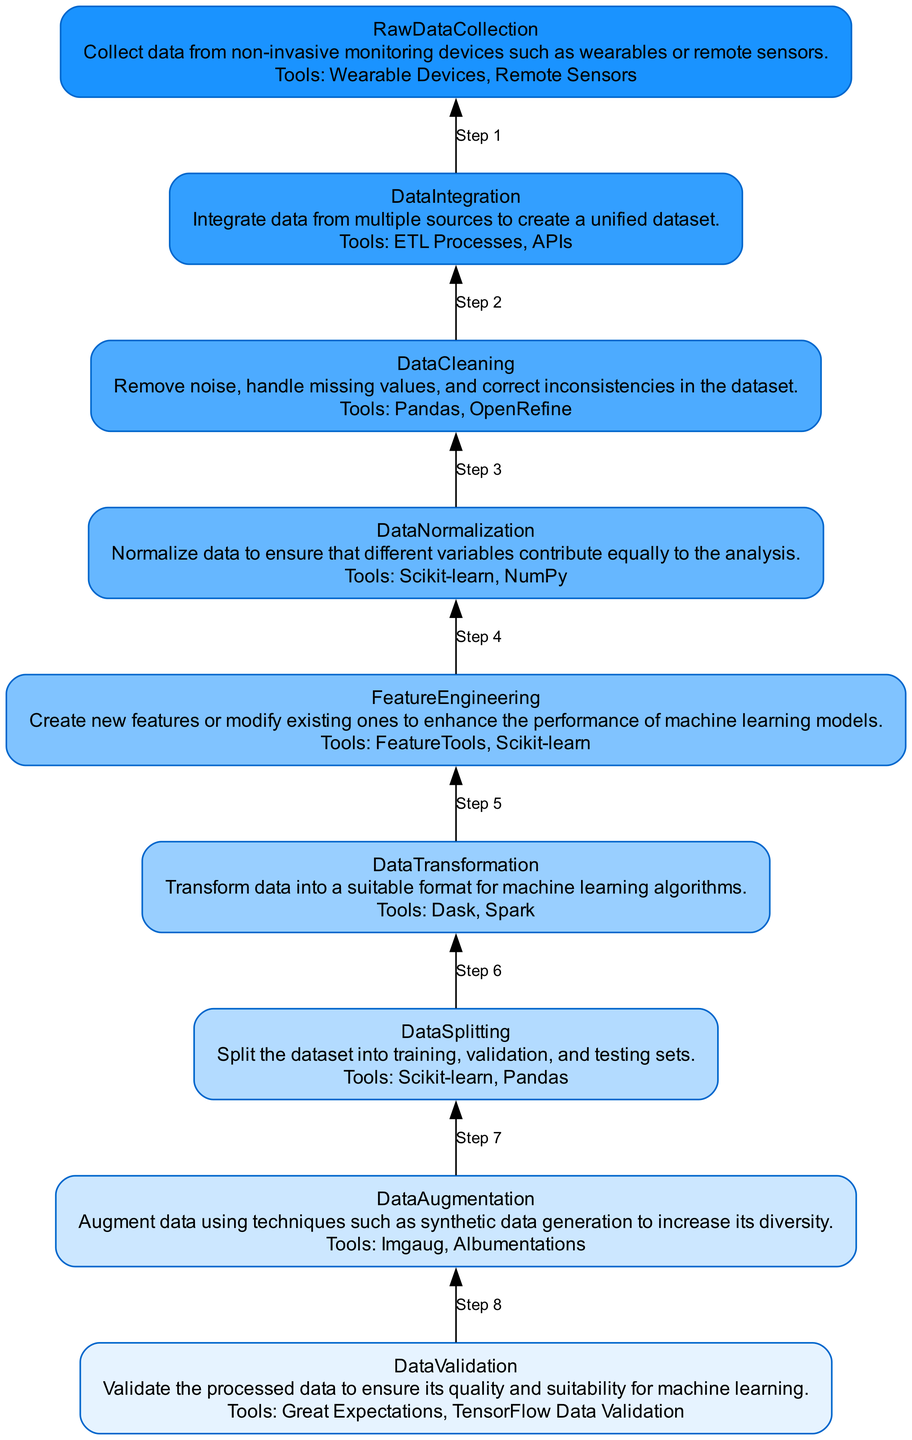What is the final step in the preprocessing pipeline? The final step is Data Validation, which is positioned at the top of the diagram.
Answer: Data Validation How many total steps are in the preprocessing pipeline? The diagram contains nine distinct steps, each one represented as a node.
Answer: Nine What is the main purpose of the Data Normalization step? The purpose of Data Normalization is to normalize data so that different variables contribute equally to the analysis. This is conveyed in the description of the Data Normalization step in the diagram.
Answer: Ensure equal contribution Which tool is used for Data Cleaning? The diagram states that Pandas is one of the tools used for Data Cleaning.
Answer: Pandas What step comes immediately before Data Transformation? Data Transformation is preceded by Feature Engineering since the flow of the diagram moves from the bottom to the top, indicating the sequence of steps.
Answer: Feature Engineering How many tools are mentioned for Data Augmentation? The diagram lists two tools for Data Augmentation: Imgaug and Albumentations. I can count these in the Tools section of the Data Augmentation node.
Answer: Two What is the relationship between Data Integration and Raw Data Collection? Data Integration follows Raw Data Collection in the sequence, indicating that data must be collected before it can be integrated into a unified dataset.
Answer: Data Integration follows Raw Data Collection What does the step after Data Splitting entail? The step after Data Splitting is Data Augmentation, where the data can be further diversified using techniques like synthetic data generation.
Answer: Data Augmentation What can be said about the tools used for Feature Engineering? The tools listed for Feature Engineering are FeatureTools and Scikit-learn, showcasing that multiple tools can enhance the performance of machine learning models.
Answer: FeatureTools and Scikit-learn 